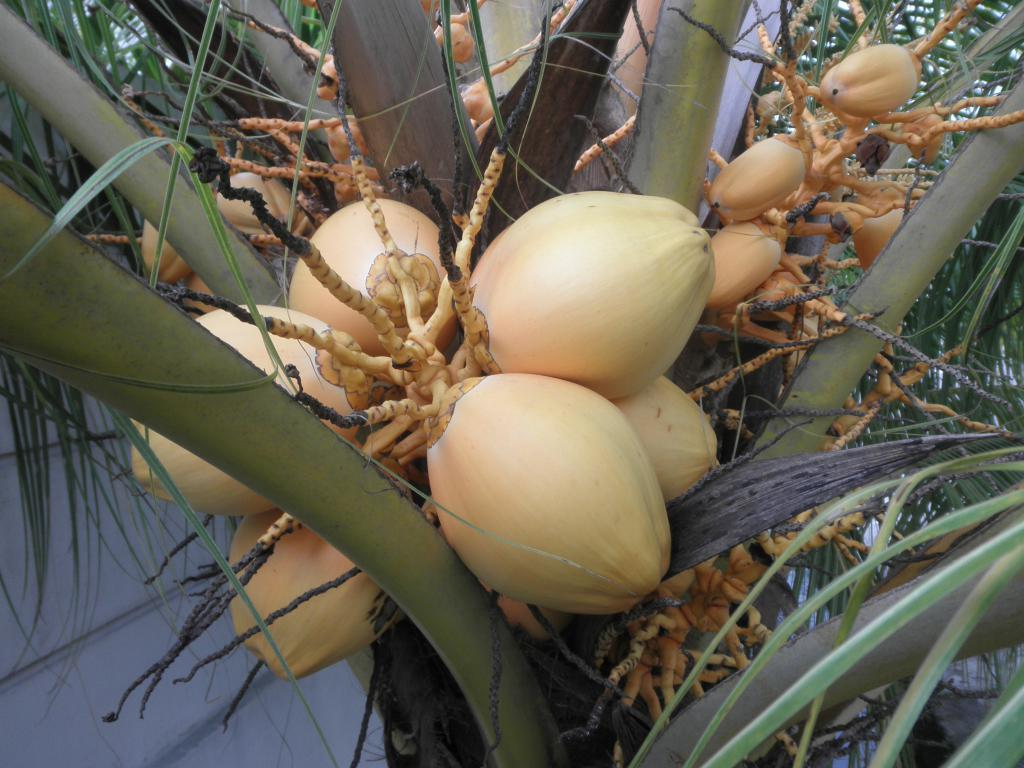What type of tree is present in the image? There is a tree with coconuts in the image. What can be seen behind the tree in the image? There is a wall visible behind the tree in the image. How much money is hanging from the tree in the image? There is no money hanging from the tree in the image; it is a tree with coconuts. What type of neck accessory can be seen on the tree in the image? There are no neck accessories present on the tree in the image; it is a tree with coconuts. 